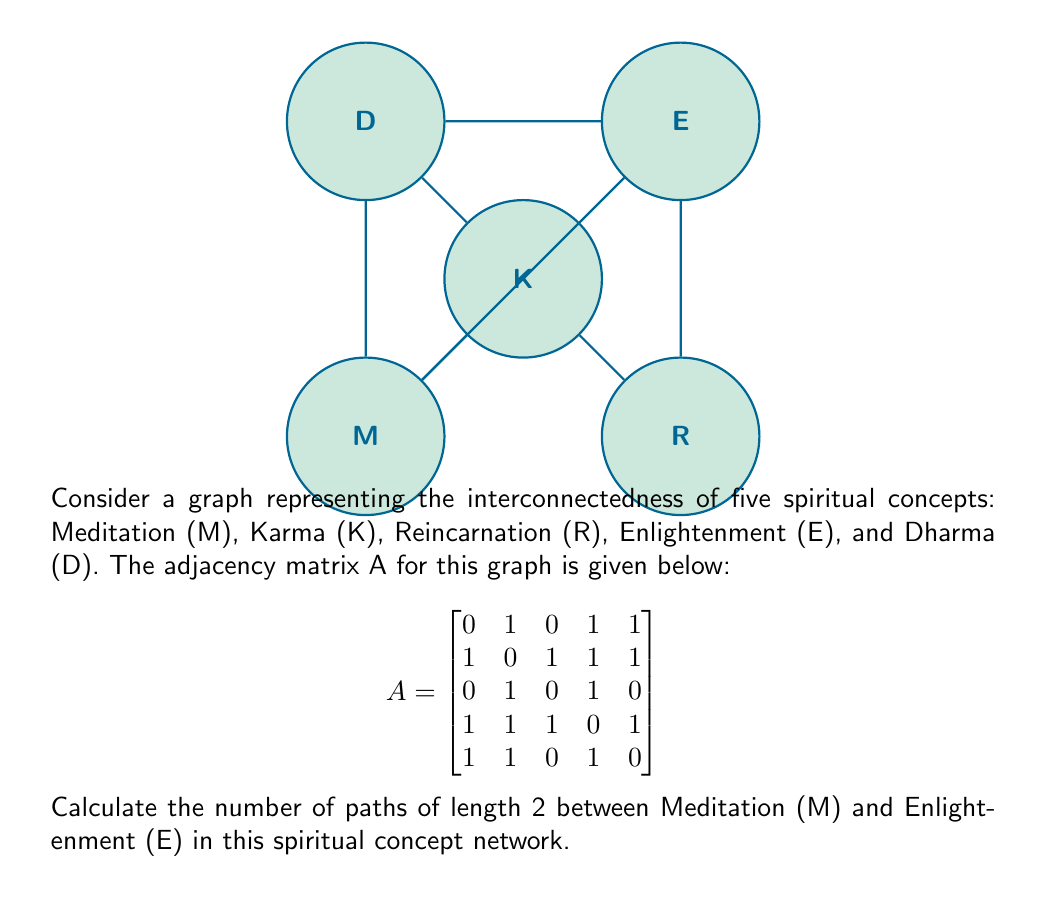Provide a solution to this math problem. To solve this problem, we'll follow these steps:

1) In graph theory, the number of paths of length 2 between two vertices i and j is given by the (i,j)th entry of A², where A is the adjacency matrix.

2) We need to calculate A². The formula for matrix multiplication is:

   $$(A^2)_{ij} = \sum_{k=1}^n A_{ik}A_{kj}$$

3) Meditation (M) is represented by the first row/column, and Enlightenment (E) by the fourth row/column. So, we need to calculate $(A^2)_{14}$.

4) Let's multiply the first row of A with the fourth column of A:

   $(A^2)_{14} = (0 \cdot 1) + (1 \cdot 1) + (0 \cdot 1) + (1 \cdot 0) + (1 \cdot 1)$

5) Simplifying:

   $(A^2)_{14} = 0 + 1 + 0 + 0 + 1 = 2$

6) Therefore, there are 2 paths of length 2 between Meditation and Enlightenment.

7) We can verify this from the graph:
   - M → K → E
   - M → D → E
Answer: 2 